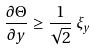Convert formula to latex. <formula><loc_0><loc_0><loc_500><loc_500>\frac { \partial \Theta } { \partial y } \geq \frac { 1 } { \sqrt { 2 } } \, \xi _ { y }</formula> 